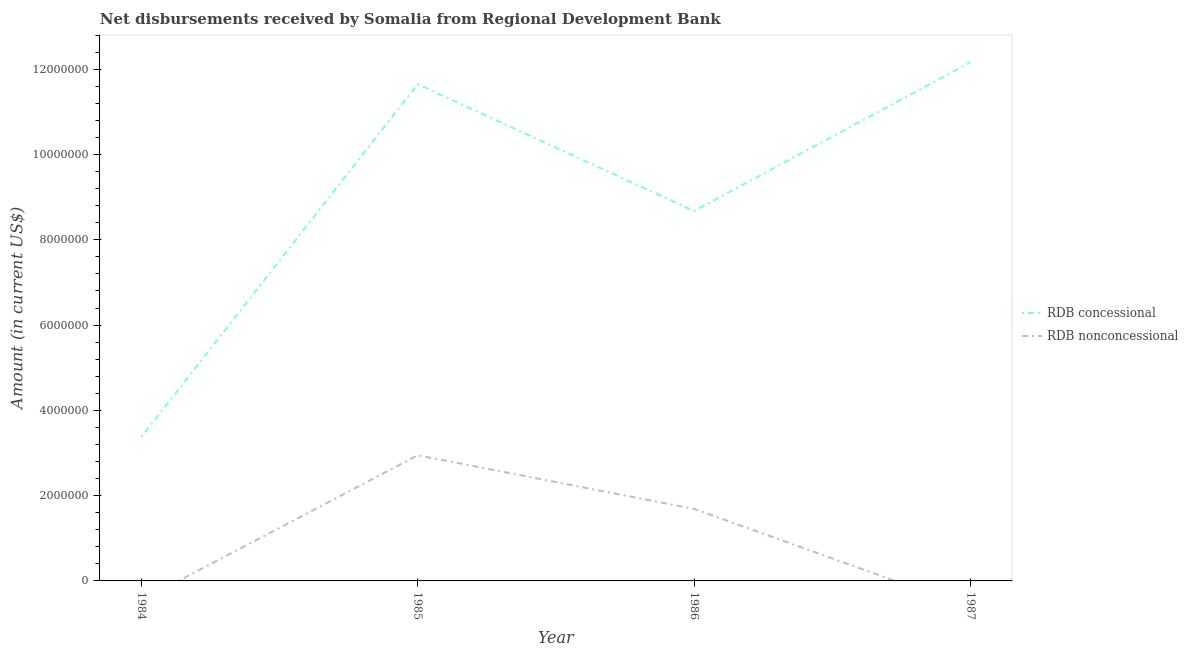Does the line corresponding to net concessional disbursements from rdb intersect with the line corresponding to net non concessional disbursements from rdb?
Offer a terse response. No. What is the net non concessional disbursements from rdb in 1985?
Your answer should be very brief. 2.95e+06. Across all years, what is the maximum net concessional disbursements from rdb?
Your answer should be very brief. 1.22e+07. Across all years, what is the minimum net non concessional disbursements from rdb?
Provide a short and direct response. 0. What is the total net concessional disbursements from rdb in the graph?
Give a very brief answer. 3.59e+07. What is the difference between the net non concessional disbursements from rdb in 1985 and that in 1986?
Keep it short and to the point. 1.26e+06. What is the difference between the net concessional disbursements from rdb in 1986 and the net non concessional disbursements from rdb in 1984?
Your response must be concise. 8.67e+06. What is the average net concessional disbursements from rdb per year?
Your response must be concise. 8.96e+06. In the year 1986, what is the difference between the net concessional disbursements from rdb and net non concessional disbursements from rdb?
Provide a succinct answer. 6.98e+06. In how many years, is the net non concessional disbursements from rdb greater than 11200000 US$?
Ensure brevity in your answer.  0. What is the ratio of the net non concessional disbursements from rdb in 1985 to that in 1986?
Offer a terse response. 1.74. Is the difference between the net non concessional disbursements from rdb in 1985 and 1986 greater than the difference between the net concessional disbursements from rdb in 1985 and 1986?
Give a very brief answer. No. What is the difference between the highest and the second highest net concessional disbursements from rdb?
Offer a very short reply. 5.18e+05. What is the difference between the highest and the lowest net concessional disbursements from rdb?
Your answer should be compact. 8.79e+06. Is the net concessional disbursements from rdb strictly greater than the net non concessional disbursements from rdb over the years?
Your answer should be very brief. Yes. Is the net concessional disbursements from rdb strictly less than the net non concessional disbursements from rdb over the years?
Your answer should be very brief. No. What is the difference between two consecutive major ticks on the Y-axis?
Provide a short and direct response. 2.00e+06. Are the values on the major ticks of Y-axis written in scientific E-notation?
Your answer should be very brief. No. Does the graph contain any zero values?
Offer a very short reply. Yes. Where does the legend appear in the graph?
Your answer should be very brief. Center right. How many legend labels are there?
Make the answer very short. 2. How are the legend labels stacked?
Make the answer very short. Vertical. What is the title of the graph?
Your response must be concise. Net disbursements received by Somalia from Regional Development Bank. Does "Arms exports" appear as one of the legend labels in the graph?
Provide a short and direct response. No. What is the label or title of the X-axis?
Offer a very short reply. Year. What is the label or title of the Y-axis?
Your response must be concise. Amount (in current US$). What is the Amount (in current US$) of RDB concessional in 1984?
Offer a terse response. 3.37e+06. What is the Amount (in current US$) of RDB nonconcessional in 1984?
Keep it short and to the point. 0. What is the Amount (in current US$) in RDB concessional in 1985?
Give a very brief answer. 1.16e+07. What is the Amount (in current US$) in RDB nonconcessional in 1985?
Your response must be concise. 2.95e+06. What is the Amount (in current US$) in RDB concessional in 1986?
Give a very brief answer. 8.67e+06. What is the Amount (in current US$) in RDB nonconcessional in 1986?
Your answer should be very brief. 1.69e+06. What is the Amount (in current US$) in RDB concessional in 1987?
Make the answer very short. 1.22e+07. Across all years, what is the maximum Amount (in current US$) in RDB concessional?
Keep it short and to the point. 1.22e+07. Across all years, what is the maximum Amount (in current US$) in RDB nonconcessional?
Keep it short and to the point. 2.95e+06. Across all years, what is the minimum Amount (in current US$) of RDB concessional?
Keep it short and to the point. 3.37e+06. What is the total Amount (in current US$) in RDB concessional in the graph?
Your answer should be very brief. 3.59e+07. What is the total Amount (in current US$) in RDB nonconcessional in the graph?
Offer a very short reply. 4.64e+06. What is the difference between the Amount (in current US$) of RDB concessional in 1984 and that in 1985?
Offer a very short reply. -8.27e+06. What is the difference between the Amount (in current US$) of RDB concessional in 1984 and that in 1986?
Your answer should be very brief. -5.30e+06. What is the difference between the Amount (in current US$) of RDB concessional in 1984 and that in 1987?
Your answer should be compact. -8.79e+06. What is the difference between the Amount (in current US$) in RDB concessional in 1985 and that in 1986?
Provide a succinct answer. 2.97e+06. What is the difference between the Amount (in current US$) of RDB nonconcessional in 1985 and that in 1986?
Your response must be concise. 1.26e+06. What is the difference between the Amount (in current US$) in RDB concessional in 1985 and that in 1987?
Your response must be concise. -5.18e+05. What is the difference between the Amount (in current US$) of RDB concessional in 1986 and that in 1987?
Give a very brief answer. -3.49e+06. What is the difference between the Amount (in current US$) in RDB concessional in 1984 and the Amount (in current US$) in RDB nonconcessional in 1985?
Keep it short and to the point. 4.27e+05. What is the difference between the Amount (in current US$) in RDB concessional in 1984 and the Amount (in current US$) in RDB nonconcessional in 1986?
Ensure brevity in your answer.  1.68e+06. What is the difference between the Amount (in current US$) in RDB concessional in 1985 and the Amount (in current US$) in RDB nonconcessional in 1986?
Your answer should be very brief. 9.96e+06. What is the average Amount (in current US$) in RDB concessional per year?
Your answer should be very brief. 8.96e+06. What is the average Amount (in current US$) in RDB nonconcessional per year?
Keep it short and to the point. 1.16e+06. In the year 1985, what is the difference between the Amount (in current US$) of RDB concessional and Amount (in current US$) of RDB nonconcessional?
Keep it short and to the point. 8.70e+06. In the year 1986, what is the difference between the Amount (in current US$) of RDB concessional and Amount (in current US$) of RDB nonconcessional?
Your response must be concise. 6.98e+06. What is the ratio of the Amount (in current US$) in RDB concessional in 1984 to that in 1985?
Offer a terse response. 0.29. What is the ratio of the Amount (in current US$) of RDB concessional in 1984 to that in 1986?
Ensure brevity in your answer.  0.39. What is the ratio of the Amount (in current US$) in RDB concessional in 1984 to that in 1987?
Provide a short and direct response. 0.28. What is the ratio of the Amount (in current US$) in RDB concessional in 1985 to that in 1986?
Give a very brief answer. 1.34. What is the ratio of the Amount (in current US$) in RDB nonconcessional in 1985 to that in 1986?
Provide a succinct answer. 1.74. What is the ratio of the Amount (in current US$) of RDB concessional in 1985 to that in 1987?
Provide a succinct answer. 0.96. What is the ratio of the Amount (in current US$) in RDB concessional in 1986 to that in 1987?
Offer a terse response. 0.71. What is the difference between the highest and the second highest Amount (in current US$) of RDB concessional?
Make the answer very short. 5.18e+05. What is the difference between the highest and the lowest Amount (in current US$) in RDB concessional?
Your response must be concise. 8.79e+06. What is the difference between the highest and the lowest Amount (in current US$) of RDB nonconcessional?
Your response must be concise. 2.95e+06. 